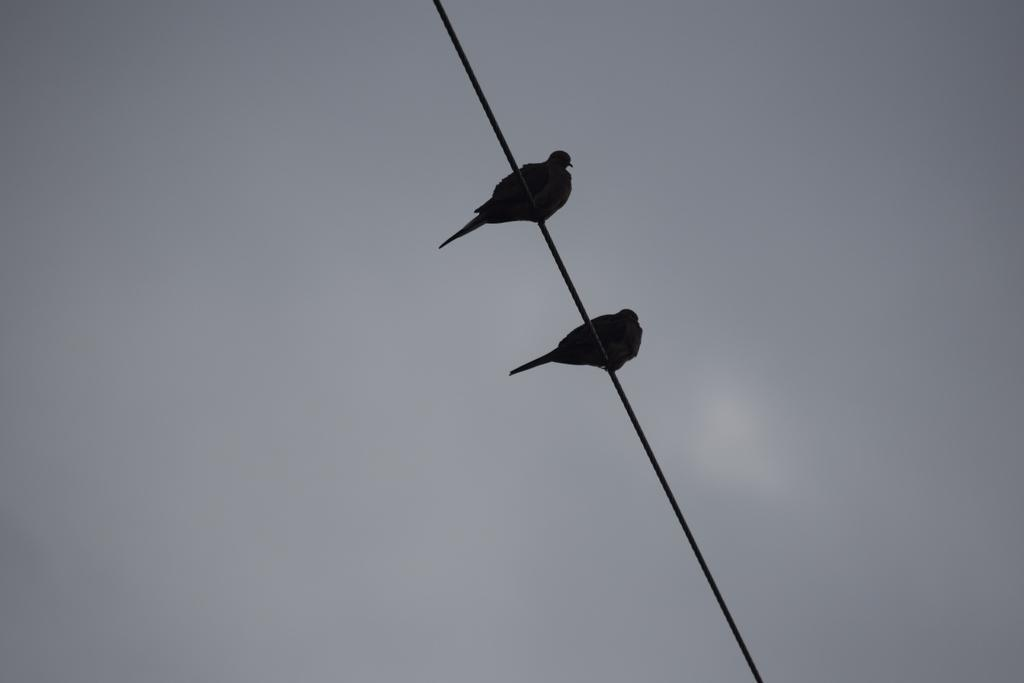How many birds are present in the image? There are two birds in the image. Where are the birds located? The birds are standing on an electric cable. What can be seen in the background of the image? There is sky visible in the background of the image. What decision did the birds make before standing on the electric cable in the image? There is no information about any decision made by the birds in the image. 